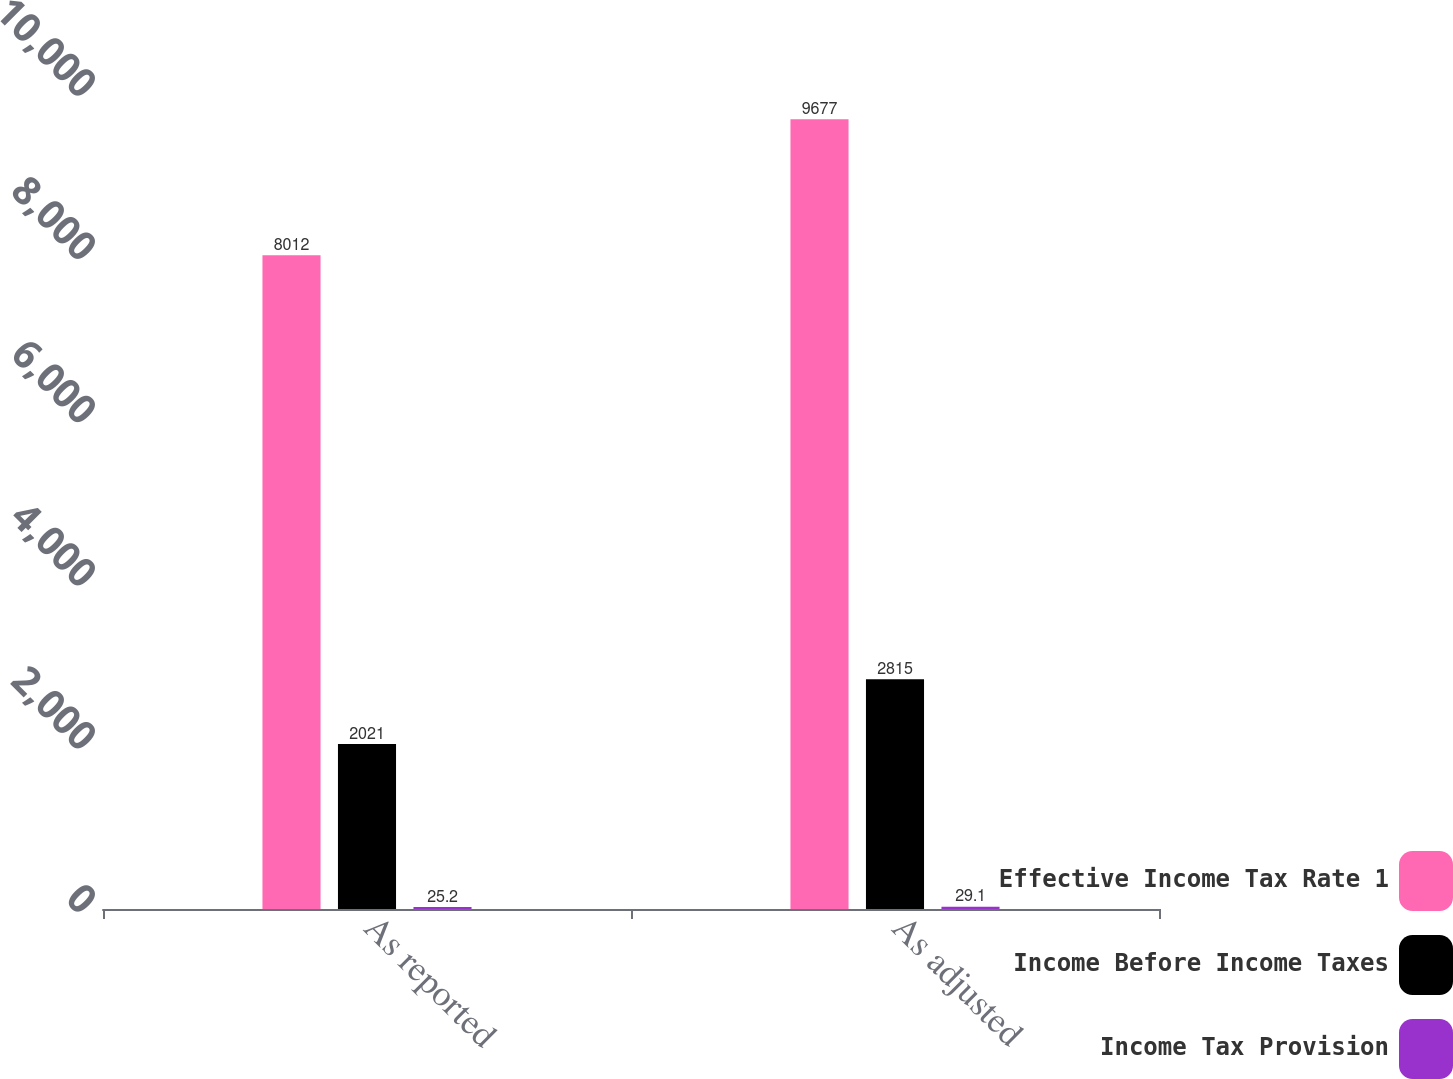<chart> <loc_0><loc_0><loc_500><loc_500><stacked_bar_chart><ecel><fcel>As reported<fcel>As adjusted<nl><fcel>Effective Income Tax Rate 1<fcel>8012<fcel>9677<nl><fcel>Income Before Income Taxes<fcel>2021<fcel>2815<nl><fcel>Income Tax Provision<fcel>25.2<fcel>29.1<nl></chart> 